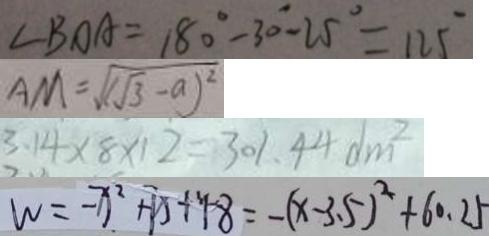<formula> <loc_0><loc_0><loc_500><loc_500>\angle B O A = 1 8 0 ^ { \circ } - 3 0 ^ { \circ } - 2 5 ^ { \circ } = 1 2 5 ^ { \circ } 
 A M = \sqrt { ( \sqrt { 3 } - a ) ^ { 2 } } 
 3 . 1 4 \times 8 \times 1 2 = 3 0 1 . 4 4 d m ^ { 2 } 
 w = - x ^ { 2 } + 7 x + 4 8 = - ( x - 3 . 5 ) ^ { 2 } + 6 0 . 2 5</formula> 